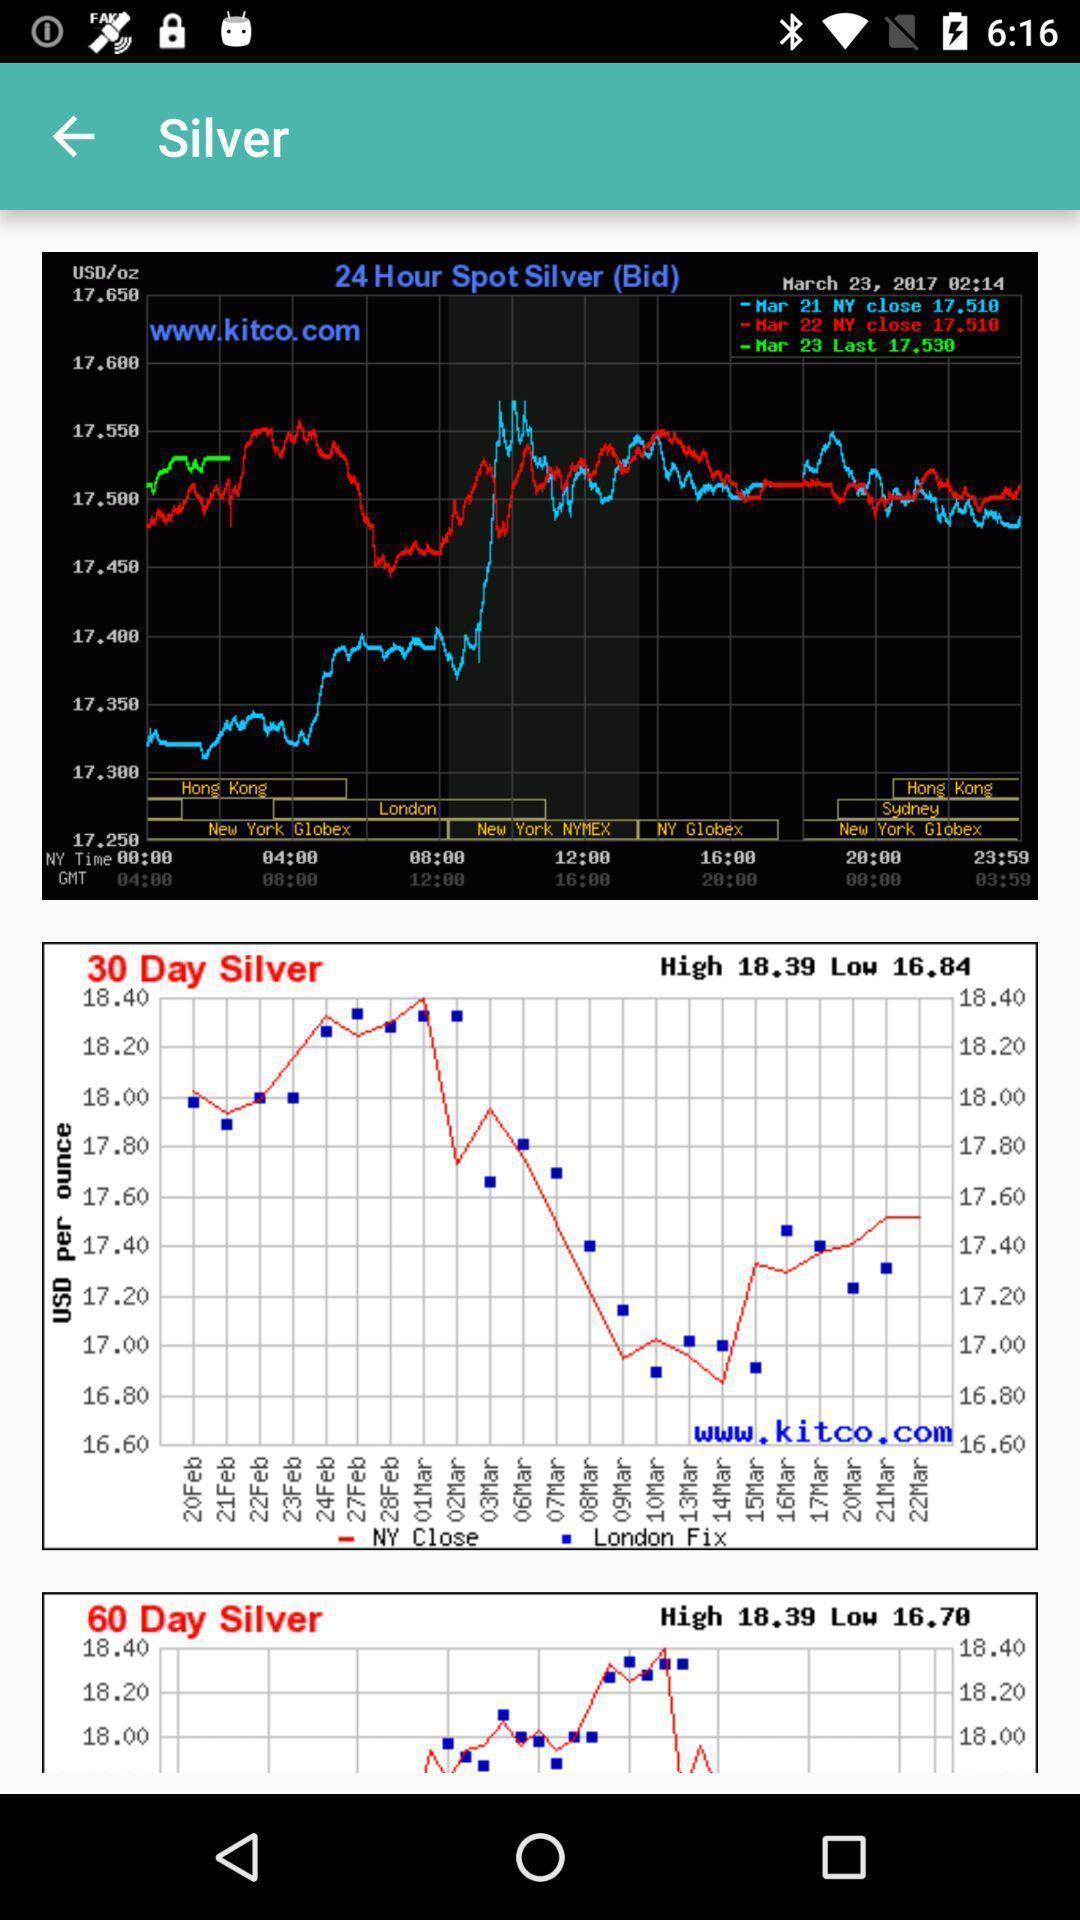Describe this image in words. Screen shows graphs. 